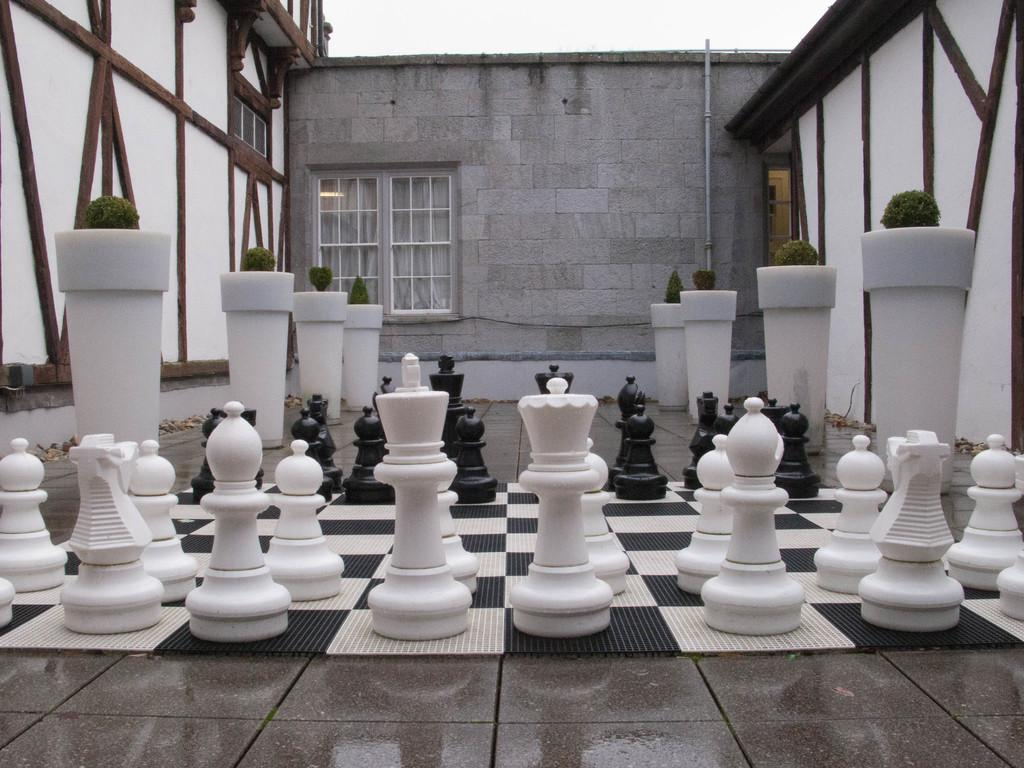What game is being played on the board in the image? The image features a chess board, so the game being played is chess. What material are the chess pieces made of? The chess pieces are made of stones. What type of plants can be seen in the image? There are houseplants in the image. What architectural feature is present in the image? There is a wall in the image. What can be seen through the wall in the image? There are windows in the image. What is the purpose of the pipe in the image? The purpose of the pipe in the image is not clear, but it may be part of a plumbing or ventilation system. What is visible in the background of the image? The sky is visible in the image. Can we determine the time of day the image was taken? Yes, the image was likely taken during the day, as the sky is visible and not dark. How many mice are hiding under the chess board in the image? There are no mice visible in the image, and therefore no mice can be hiding under the chess board. What is the smallest unit of time that can be measured in the image? The image does not depict any specific units of time, so it is not possible to determine the smallest unit of time that can be measured. 